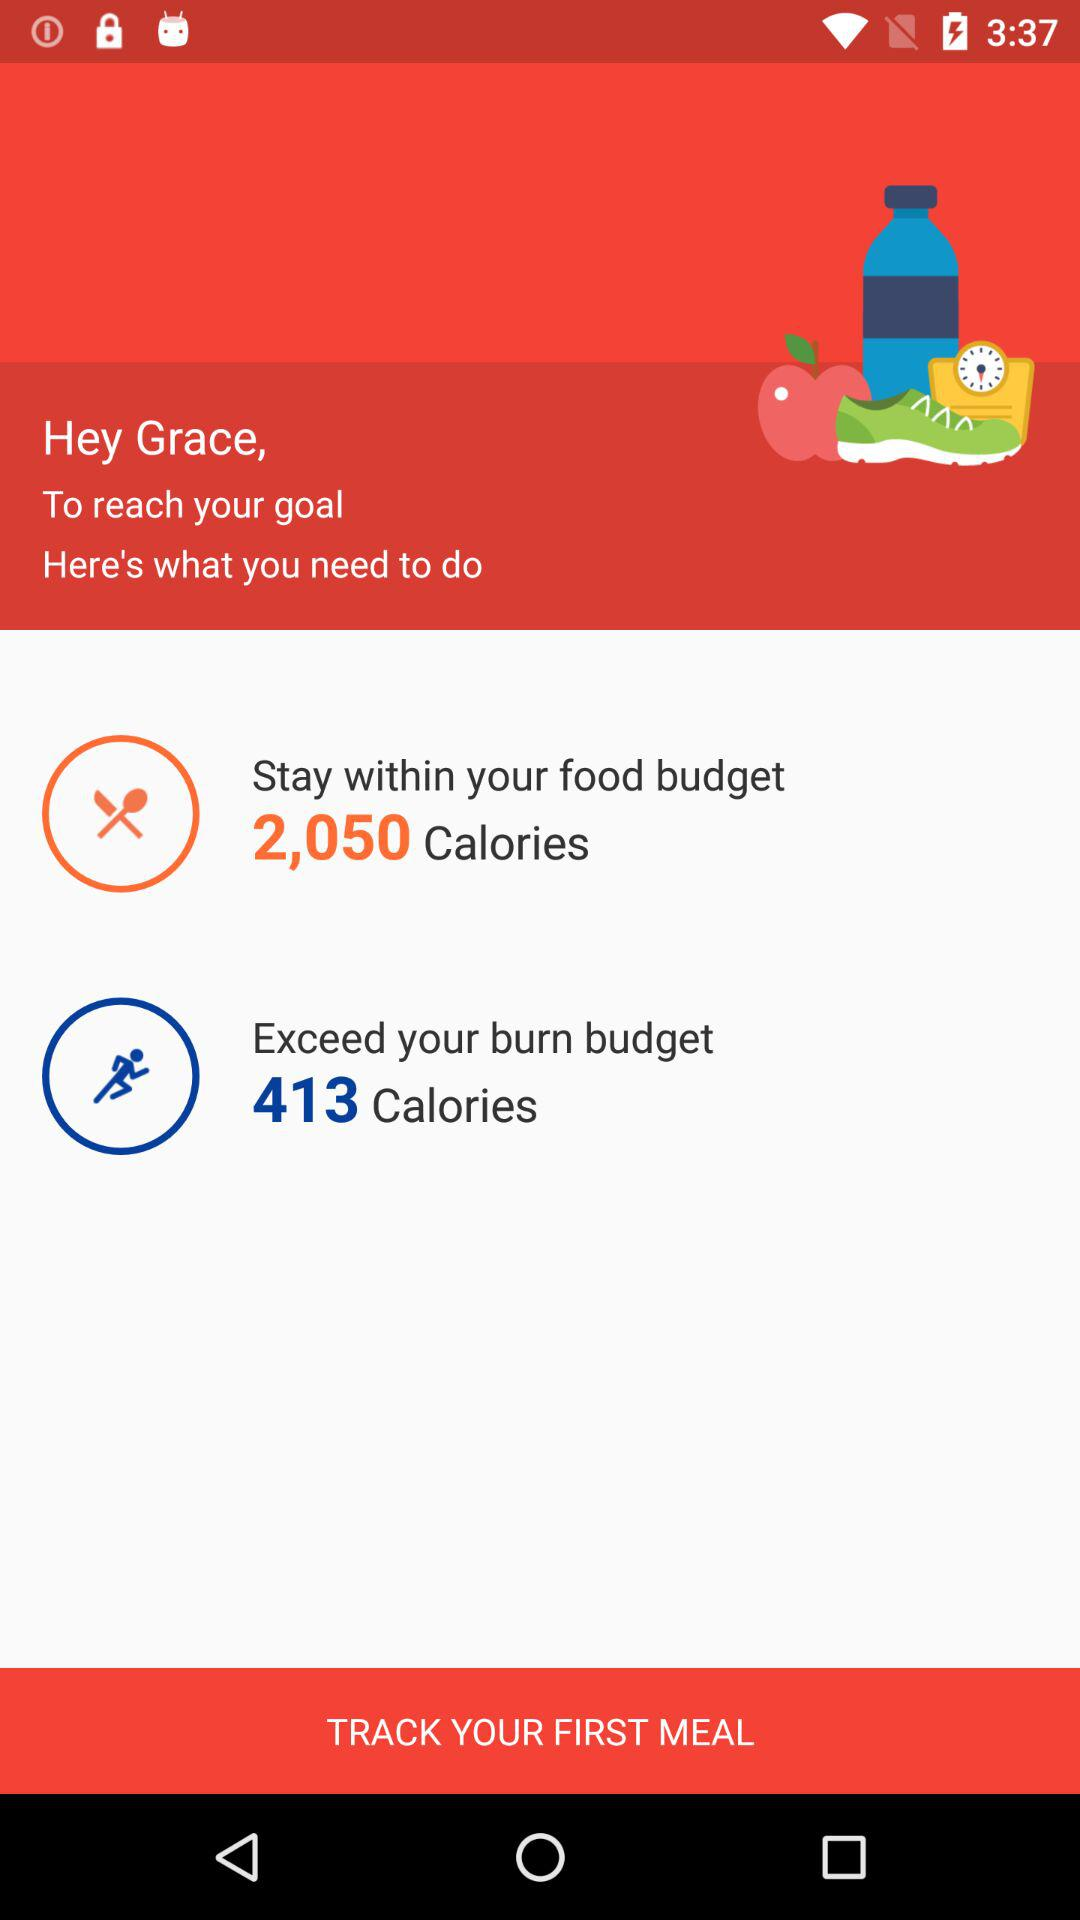How much calories for food budget?
When the provided information is insufficient, respond with <no answer>. <no answer> 